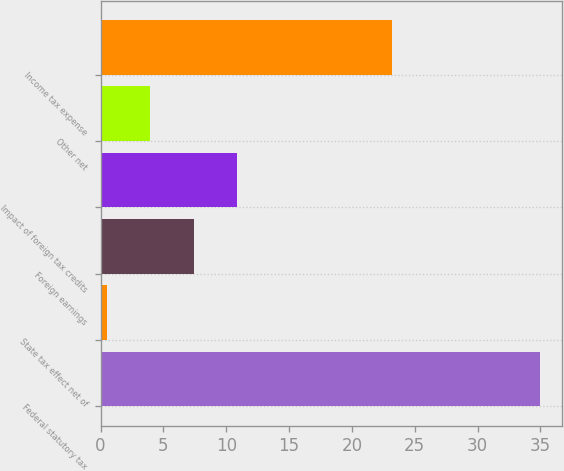Convert chart. <chart><loc_0><loc_0><loc_500><loc_500><bar_chart><fcel>Federal statutory tax<fcel>State tax effect net of<fcel>Foreign earnings<fcel>Impact of foreign tax credits<fcel>Other net<fcel>Income tax expense<nl><fcel>35<fcel>0.5<fcel>7.4<fcel>10.85<fcel>3.95<fcel>23.2<nl></chart> 